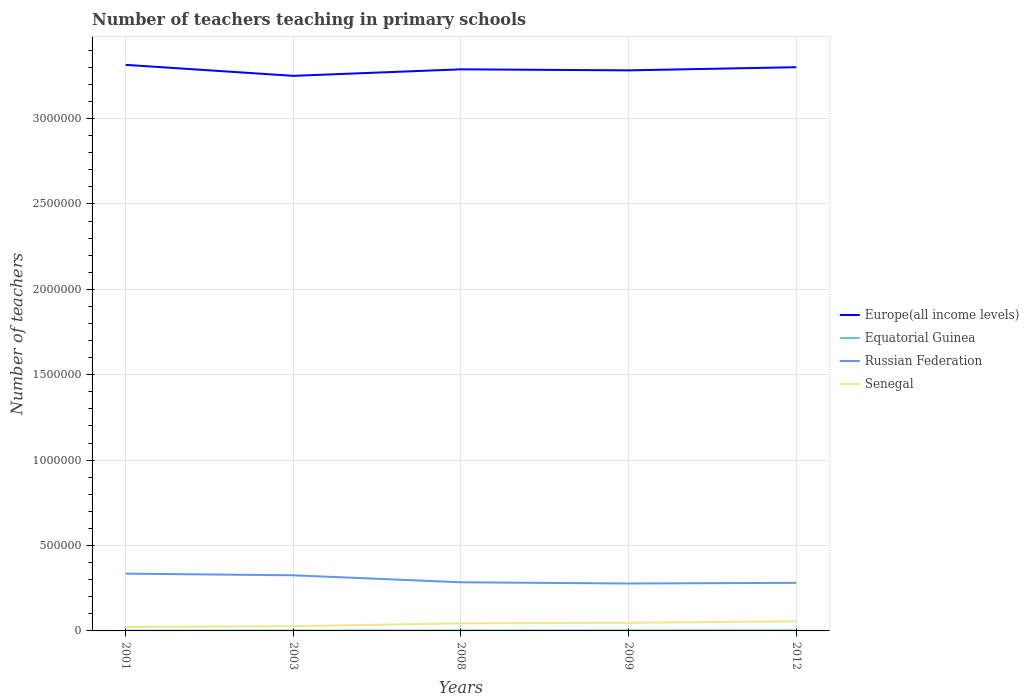Does the line corresponding to Europe(all income levels) intersect with the line corresponding to Equatorial Guinea?
Make the answer very short. No. Is the number of lines equal to the number of legend labels?
Keep it short and to the point. Yes. Across all years, what is the maximum number of teachers teaching in primary schools in Russian Federation?
Keep it short and to the point. 2.78e+05. In which year was the number of teachers teaching in primary schools in Europe(all income levels) maximum?
Your answer should be compact. 2003. What is the total number of teachers teaching in primary schools in Russian Federation in the graph?
Ensure brevity in your answer.  -3846. What is the difference between the highest and the second highest number of teachers teaching in primary schools in Europe(all income levels)?
Ensure brevity in your answer.  6.43e+04. How many lines are there?
Your response must be concise. 4. Are the values on the major ticks of Y-axis written in scientific E-notation?
Your answer should be very brief. No. How are the legend labels stacked?
Offer a terse response. Vertical. What is the title of the graph?
Your response must be concise. Number of teachers teaching in primary schools. What is the label or title of the Y-axis?
Make the answer very short. Number of teachers. What is the Number of teachers in Europe(all income levels) in 2001?
Your answer should be compact. 3.31e+06. What is the Number of teachers in Equatorial Guinea in 2001?
Your answer should be very brief. 1810. What is the Number of teachers of Russian Federation in 2001?
Offer a terse response. 3.36e+05. What is the Number of teachers of Senegal in 2001?
Keep it short and to the point. 2.28e+04. What is the Number of teachers of Europe(all income levels) in 2003?
Provide a succinct answer. 3.25e+06. What is the Number of teachers in Equatorial Guinea in 2003?
Provide a short and direct response. 2307. What is the Number of teachers in Russian Federation in 2003?
Your answer should be very brief. 3.26e+05. What is the Number of teachers of Senegal in 2003?
Offer a very short reply. 2.80e+04. What is the Number of teachers in Europe(all income levels) in 2008?
Your answer should be compact. 3.29e+06. What is the Number of teachers in Equatorial Guinea in 2008?
Keep it short and to the point. 2900. What is the Number of teachers in Russian Federation in 2008?
Your answer should be compact. 2.85e+05. What is the Number of teachers of Senegal in 2008?
Offer a terse response. 4.44e+04. What is the Number of teachers of Europe(all income levels) in 2009?
Your answer should be very brief. 3.28e+06. What is the Number of teachers of Equatorial Guinea in 2009?
Provide a succinct answer. 3403. What is the Number of teachers of Russian Federation in 2009?
Your answer should be very brief. 2.78e+05. What is the Number of teachers in Senegal in 2009?
Your answer should be very brief. 4.77e+04. What is the Number of teachers in Europe(all income levels) in 2012?
Offer a terse response. 3.30e+06. What is the Number of teachers in Equatorial Guinea in 2012?
Offer a terse response. 3517. What is the Number of teachers of Russian Federation in 2012?
Your answer should be compact. 2.82e+05. What is the Number of teachers of Senegal in 2012?
Keep it short and to the point. 5.63e+04. Across all years, what is the maximum Number of teachers of Europe(all income levels)?
Provide a succinct answer. 3.31e+06. Across all years, what is the maximum Number of teachers of Equatorial Guinea?
Your answer should be very brief. 3517. Across all years, what is the maximum Number of teachers of Russian Federation?
Offer a terse response. 3.36e+05. Across all years, what is the maximum Number of teachers of Senegal?
Provide a short and direct response. 5.63e+04. Across all years, what is the minimum Number of teachers of Europe(all income levels)?
Make the answer very short. 3.25e+06. Across all years, what is the minimum Number of teachers in Equatorial Guinea?
Provide a succinct answer. 1810. Across all years, what is the minimum Number of teachers of Russian Federation?
Keep it short and to the point. 2.78e+05. Across all years, what is the minimum Number of teachers in Senegal?
Keep it short and to the point. 2.28e+04. What is the total Number of teachers in Europe(all income levels) in the graph?
Give a very brief answer. 1.64e+07. What is the total Number of teachers of Equatorial Guinea in the graph?
Give a very brief answer. 1.39e+04. What is the total Number of teachers in Russian Federation in the graph?
Your answer should be compact. 1.51e+06. What is the total Number of teachers in Senegal in the graph?
Make the answer very short. 1.99e+05. What is the difference between the Number of teachers in Europe(all income levels) in 2001 and that in 2003?
Offer a very short reply. 6.43e+04. What is the difference between the Number of teachers in Equatorial Guinea in 2001 and that in 2003?
Ensure brevity in your answer.  -497. What is the difference between the Number of teachers of Russian Federation in 2001 and that in 2003?
Offer a very short reply. 9833. What is the difference between the Number of teachers of Senegal in 2001 and that in 2003?
Provide a succinct answer. -5138. What is the difference between the Number of teachers of Europe(all income levels) in 2001 and that in 2008?
Offer a very short reply. 2.61e+04. What is the difference between the Number of teachers in Equatorial Guinea in 2001 and that in 2008?
Make the answer very short. -1090. What is the difference between the Number of teachers of Russian Federation in 2001 and that in 2008?
Ensure brevity in your answer.  5.07e+04. What is the difference between the Number of teachers in Senegal in 2001 and that in 2008?
Your response must be concise. -2.16e+04. What is the difference between the Number of teachers of Europe(all income levels) in 2001 and that in 2009?
Make the answer very short. 3.22e+04. What is the difference between the Number of teachers in Equatorial Guinea in 2001 and that in 2009?
Ensure brevity in your answer.  -1593. What is the difference between the Number of teachers in Russian Federation in 2001 and that in 2009?
Offer a very short reply. 5.78e+04. What is the difference between the Number of teachers of Senegal in 2001 and that in 2009?
Your answer should be compact. -2.49e+04. What is the difference between the Number of teachers of Europe(all income levels) in 2001 and that in 2012?
Provide a succinct answer. 1.37e+04. What is the difference between the Number of teachers of Equatorial Guinea in 2001 and that in 2012?
Your response must be concise. -1707. What is the difference between the Number of teachers of Russian Federation in 2001 and that in 2012?
Make the answer very short. 5.40e+04. What is the difference between the Number of teachers of Senegal in 2001 and that in 2012?
Your response must be concise. -3.35e+04. What is the difference between the Number of teachers of Europe(all income levels) in 2003 and that in 2008?
Ensure brevity in your answer.  -3.81e+04. What is the difference between the Number of teachers in Equatorial Guinea in 2003 and that in 2008?
Your answer should be compact. -593. What is the difference between the Number of teachers of Russian Federation in 2003 and that in 2008?
Ensure brevity in your answer.  4.09e+04. What is the difference between the Number of teachers of Senegal in 2003 and that in 2008?
Ensure brevity in your answer.  -1.65e+04. What is the difference between the Number of teachers in Europe(all income levels) in 2003 and that in 2009?
Make the answer very short. -3.21e+04. What is the difference between the Number of teachers in Equatorial Guinea in 2003 and that in 2009?
Offer a terse response. -1096. What is the difference between the Number of teachers in Russian Federation in 2003 and that in 2009?
Ensure brevity in your answer.  4.80e+04. What is the difference between the Number of teachers in Senegal in 2003 and that in 2009?
Your answer should be very brief. -1.97e+04. What is the difference between the Number of teachers of Europe(all income levels) in 2003 and that in 2012?
Provide a succinct answer. -5.06e+04. What is the difference between the Number of teachers of Equatorial Guinea in 2003 and that in 2012?
Give a very brief answer. -1210. What is the difference between the Number of teachers in Russian Federation in 2003 and that in 2012?
Provide a succinct answer. 4.42e+04. What is the difference between the Number of teachers in Senegal in 2003 and that in 2012?
Ensure brevity in your answer.  -2.83e+04. What is the difference between the Number of teachers of Europe(all income levels) in 2008 and that in 2009?
Offer a terse response. 6013.25. What is the difference between the Number of teachers in Equatorial Guinea in 2008 and that in 2009?
Ensure brevity in your answer.  -503. What is the difference between the Number of teachers of Russian Federation in 2008 and that in 2009?
Give a very brief answer. 7132. What is the difference between the Number of teachers in Senegal in 2008 and that in 2009?
Keep it short and to the point. -3269. What is the difference between the Number of teachers in Europe(all income levels) in 2008 and that in 2012?
Provide a short and direct response. -1.24e+04. What is the difference between the Number of teachers in Equatorial Guinea in 2008 and that in 2012?
Keep it short and to the point. -617. What is the difference between the Number of teachers in Russian Federation in 2008 and that in 2012?
Offer a terse response. 3286. What is the difference between the Number of teachers of Senegal in 2008 and that in 2012?
Give a very brief answer. -1.19e+04. What is the difference between the Number of teachers in Europe(all income levels) in 2009 and that in 2012?
Keep it short and to the point. -1.84e+04. What is the difference between the Number of teachers in Equatorial Guinea in 2009 and that in 2012?
Keep it short and to the point. -114. What is the difference between the Number of teachers in Russian Federation in 2009 and that in 2012?
Give a very brief answer. -3846. What is the difference between the Number of teachers in Senegal in 2009 and that in 2012?
Offer a terse response. -8599. What is the difference between the Number of teachers of Europe(all income levels) in 2001 and the Number of teachers of Equatorial Guinea in 2003?
Your response must be concise. 3.31e+06. What is the difference between the Number of teachers in Europe(all income levels) in 2001 and the Number of teachers in Russian Federation in 2003?
Offer a very short reply. 2.99e+06. What is the difference between the Number of teachers in Europe(all income levels) in 2001 and the Number of teachers in Senegal in 2003?
Your answer should be very brief. 3.29e+06. What is the difference between the Number of teachers in Equatorial Guinea in 2001 and the Number of teachers in Russian Federation in 2003?
Give a very brief answer. -3.24e+05. What is the difference between the Number of teachers in Equatorial Guinea in 2001 and the Number of teachers in Senegal in 2003?
Offer a very short reply. -2.61e+04. What is the difference between the Number of teachers of Russian Federation in 2001 and the Number of teachers of Senegal in 2003?
Provide a succinct answer. 3.08e+05. What is the difference between the Number of teachers of Europe(all income levels) in 2001 and the Number of teachers of Equatorial Guinea in 2008?
Make the answer very short. 3.31e+06. What is the difference between the Number of teachers of Europe(all income levels) in 2001 and the Number of teachers of Russian Federation in 2008?
Your answer should be very brief. 3.03e+06. What is the difference between the Number of teachers of Europe(all income levels) in 2001 and the Number of teachers of Senegal in 2008?
Give a very brief answer. 3.27e+06. What is the difference between the Number of teachers of Equatorial Guinea in 2001 and the Number of teachers of Russian Federation in 2008?
Make the answer very short. -2.83e+05. What is the difference between the Number of teachers of Equatorial Guinea in 2001 and the Number of teachers of Senegal in 2008?
Provide a short and direct response. -4.26e+04. What is the difference between the Number of teachers in Russian Federation in 2001 and the Number of teachers in Senegal in 2008?
Your response must be concise. 2.91e+05. What is the difference between the Number of teachers of Europe(all income levels) in 2001 and the Number of teachers of Equatorial Guinea in 2009?
Offer a terse response. 3.31e+06. What is the difference between the Number of teachers in Europe(all income levels) in 2001 and the Number of teachers in Russian Federation in 2009?
Provide a succinct answer. 3.04e+06. What is the difference between the Number of teachers in Europe(all income levels) in 2001 and the Number of teachers in Senegal in 2009?
Offer a very short reply. 3.27e+06. What is the difference between the Number of teachers of Equatorial Guinea in 2001 and the Number of teachers of Russian Federation in 2009?
Offer a very short reply. -2.76e+05. What is the difference between the Number of teachers of Equatorial Guinea in 2001 and the Number of teachers of Senegal in 2009?
Your answer should be compact. -4.59e+04. What is the difference between the Number of teachers in Russian Federation in 2001 and the Number of teachers in Senegal in 2009?
Provide a succinct answer. 2.88e+05. What is the difference between the Number of teachers of Europe(all income levels) in 2001 and the Number of teachers of Equatorial Guinea in 2012?
Your answer should be very brief. 3.31e+06. What is the difference between the Number of teachers of Europe(all income levels) in 2001 and the Number of teachers of Russian Federation in 2012?
Give a very brief answer. 3.03e+06. What is the difference between the Number of teachers in Europe(all income levels) in 2001 and the Number of teachers in Senegal in 2012?
Your answer should be very brief. 3.26e+06. What is the difference between the Number of teachers in Equatorial Guinea in 2001 and the Number of teachers in Russian Federation in 2012?
Make the answer very short. -2.80e+05. What is the difference between the Number of teachers in Equatorial Guinea in 2001 and the Number of teachers in Senegal in 2012?
Provide a short and direct response. -5.45e+04. What is the difference between the Number of teachers of Russian Federation in 2001 and the Number of teachers of Senegal in 2012?
Make the answer very short. 2.79e+05. What is the difference between the Number of teachers in Europe(all income levels) in 2003 and the Number of teachers in Equatorial Guinea in 2008?
Your response must be concise. 3.25e+06. What is the difference between the Number of teachers in Europe(all income levels) in 2003 and the Number of teachers in Russian Federation in 2008?
Offer a very short reply. 2.97e+06. What is the difference between the Number of teachers of Europe(all income levels) in 2003 and the Number of teachers of Senegal in 2008?
Ensure brevity in your answer.  3.21e+06. What is the difference between the Number of teachers of Equatorial Guinea in 2003 and the Number of teachers of Russian Federation in 2008?
Your answer should be compact. -2.82e+05. What is the difference between the Number of teachers in Equatorial Guinea in 2003 and the Number of teachers in Senegal in 2008?
Provide a succinct answer. -4.21e+04. What is the difference between the Number of teachers in Russian Federation in 2003 and the Number of teachers in Senegal in 2008?
Give a very brief answer. 2.81e+05. What is the difference between the Number of teachers in Europe(all income levels) in 2003 and the Number of teachers in Equatorial Guinea in 2009?
Ensure brevity in your answer.  3.25e+06. What is the difference between the Number of teachers in Europe(all income levels) in 2003 and the Number of teachers in Russian Federation in 2009?
Give a very brief answer. 2.97e+06. What is the difference between the Number of teachers in Europe(all income levels) in 2003 and the Number of teachers in Senegal in 2009?
Your answer should be very brief. 3.20e+06. What is the difference between the Number of teachers in Equatorial Guinea in 2003 and the Number of teachers in Russian Federation in 2009?
Your response must be concise. -2.75e+05. What is the difference between the Number of teachers of Equatorial Guinea in 2003 and the Number of teachers of Senegal in 2009?
Your response must be concise. -4.54e+04. What is the difference between the Number of teachers in Russian Federation in 2003 and the Number of teachers in Senegal in 2009?
Offer a very short reply. 2.78e+05. What is the difference between the Number of teachers in Europe(all income levels) in 2003 and the Number of teachers in Equatorial Guinea in 2012?
Your answer should be very brief. 3.25e+06. What is the difference between the Number of teachers of Europe(all income levels) in 2003 and the Number of teachers of Russian Federation in 2012?
Offer a very short reply. 2.97e+06. What is the difference between the Number of teachers of Europe(all income levels) in 2003 and the Number of teachers of Senegal in 2012?
Your answer should be very brief. 3.19e+06. What is the difference between the Number of teachers of Equatorial Guinea in 2003 and the Number of teachers of Russian Federation in 2012?
Offer a very short reply. -2.79e+05. What is the difference between the Number of teachers in Equatorial Guinea in 2003 and the Number of teachers in Senegal in 2012?
Your response must be concise. -5.40e+04. What is the difference between the Number of teachers in Russian Federation in 2003 and the Number of teachers in Senegal in 2012?
Offer a very short reply. 2.69e+05. What is the difference between the Number of teachers in Europe(all income levels) in 2008 and the Number of teachers in Equatorial Guinea in 2009?
Provide a short and direct response. 3.28e+06. What is the difference between the Number of teachers of Europe(all income levels) in 2008 and the Number of teachers of Russian Federation in 2009?
Keep it short and to the point. 3.01e+06. What is the difference between the Number of teachers of Europe(all income levels) in 2008 and the Number of teachers of Senegal in 2009?
Keep it short and to the point. 3.24e+06. What is the difference between the Number of teachers of Equatorial Guinea in 2008 and the Number of teachers of Russian Federation in 2009?
Offer a terse response. -2.75e+05. What is the difference between the Number of teachers of Equatorial Guinea in 2008 and the Number of teachers of Senegal in 2009?
Your answer should be compact. -4.48e+04. What is the difference between the Number of teachers of Russian Federation in 2008 and the Number of teachers of Senegal in 2009?
Your answer should be very brief. 2.37e+05. What is the difference between the Number of teachers of Europe(all income levels) in 2008 and the Number of teachers of Equatorial Guinea in 2012?
Offer a very short reply. 3.28e+06. What is the difference between the Number of teachers of Europe(all income levels) in 2008 and the Number of teachers of Russian Federation in 2012?
Your answer should be compact. 3.01e+06. What is the difference between the Number of teachers in Europe(all income levels) in 2008 and the Number of teachers in Senegal in 2012?
Your answer should be very brief. 3.23e+06. What is the difference between the Number of teachers of Equatorial Guinea in 2008 and the Number of teachers of Russian Federation in 2012?
Your response must be concise. -2.79e+05. What is the difference between the Number of teachers of Equatorial Guinea in 2008 and the Number of teachers of Senegal in 2012?
Your answer should be very brief. -5.34e+04. What is the difference between the Number of teachers of Russian Federation in 2008 and the Number of teachers of Senegal in 2012?
Your answer should be very brief. 2.29e+05. What is the difference between the Number of teachers of Europe(all income levels) in 2009 and the Number of teachers of Equatorial Guinea in 2012?
Your response must be concise. 3.28e+06. What is the difference between the Number of teachers in Europe(all income levels) in 2009 and the Number of teachers in Russian Federation in 2012?
Ensure brevity in your answer.  3.00e+06. What is the difference between the Number of teachers in Europe(all income levels) in 2009 and the Number of teachers in Senegal in 2012?
Give a very brief answer. 3.23e+06. What is the difference between the Number of teachers of Equatorial Guinea in 2009 and the Number of teachers of Russian Federation in 2012?
Your answer should be very brief. -2.78e+05. What is the difference between the Number of teachers of Equatorial Guinea in 2009 and the Number of teachers of Senegal in 2012?
Your answer should be compact. -5.29e+04. What is the difference between the Number of teachers of Russian Federation in 2009 and the Number of teachers of Senegal in 2012?
Your answer should be compact. 2.21e+05. What is the average Number of teachers in Europe(all income levels) per year?
Provide a succinct answer. 3.29e+06. What is the average Number of teachers in Equatorial Guinea per year?
Offer a very short reply. 2787.4. What is the average Number of teachers of Russian Federation per year?
Your response must be concise. 3.01e+05. What is the average Number of teachers in Senegal per year?
Provide a succinct answer. 3.98e+04. In the year 2001, what is the difference between the Number of teachers in Europe(all income levels) and Number of teachers in Equatorial Guinea?
Your response must be concise. 3.31e+06. In the year 2001, what is the difference between the Number of teachers in Europe(all income levels) and Number of teachers in Russian Federation?
Provide a short and direct response. 2.98e+06. In the year 2001, what is the difference between the Number of teachers of Europe(all income levels) and Number of teachers of Senegal?
Provide a short and direct response. 3.29e+06. In the year 2001, what is the difference between the Number of teachers of Equatorial Guinea and Number of teachers of Russian Federation?
Provide a succinct answer. -3.34e+05. In the year 2001, what is the difference between the Number of teachers in Equatorial Guinea and Number of teachers in Senegal?
Make the answer very short. -2.10e+04. In the year 2001, what is the difference between the Number of teachers in Russian Federation and Number of teachers in Senegal?
Your answer should be very brief. 3.13e+05. In the year 2003, what is the difference between the Number of teachers of Europe(all income levels) and Number of teachers of Equatorial Guinea?
Your response must be concise. 3.25e+06. In the year 2003, what is the difference between the Number of teachers of Europe(all income levels) and Number of teachers of Russian Federation?
Give a very brief answer. 2.92e+06. In the year 2003, what is the difference between the Number of teachers in Europe(all income levels) and Number of teachers in Senegal?
Provide a short and direct response. 3.22e+06. In the year 2003, what is the difference between the Number of teachers of Equatorial Guinea and Number of teachers of Russian Federation?
Your response must be concise. -3.23e+05. In the year 2003, what is the difference between the Number of teachers in Equatorial Guinea and Number of teachers in Senegal?
Your response must be concise. -2.56e+04. In the year 2003, what is the difference between the Number of teachers of Russian Federation and Number of teachers of Senegal?
Ensure brevity in your answer.  2.98e+05. In the year 2008, what is the difference between the Number of teachers in Europe(all income levels) and Number of teachers in Equatorial Guinea?
Provide a succinct answer. 3.29e+06. In the year 2008, what is the difference between the Number of teachers of Europe(all income levels) and Number of teachers of Russian Federation?
Provide a short and direct response. 3.00e+06. In the year 2008, what is the difference between the Number of teachers in Europe(all income levels) and Number of teachers in Senegal?
Make the answer very short. 3.24e+06. In the year 2008, what is the difference between the Number of teachers in Equatorial Guinea and Number of teachers in Russian Federation?
Provide a short and direct response. -2.82e+05. In the year 2008, what is the difference between the Number of teachers of Equatorial Guinea and Number of teachers of Senegal?
Offer a terse response. -4.15e+04. In the year 2008, what is the difference between the Number of teachers in Russian Federation and Number of teachers in Senegal?
Keep it short and to the point. 2.40e+05. In the year 2009, what is the difference between the Number of teachers in Europe(all income levels) and Number of teachers in Equatorial Guinea?
Give a very brief answer. 3.28e+06. In the year 2009, what is the difference between the Number of teachers in Europe(all income levels) and Number of teachers in Russian Federation?
Ensure brevity in your answer.  3.00e+06. In the year 2009, what is the difference between the Number of teachers of Europe(all income levels) and Number of teachers of Senegal?
Ensure brevity in your answer.  3.23e+06. In the year 2009, what is the difference between the Number of teachers of Equatorial Guinea and Number of teachers of Russian Federation?
Provide a succinct answer. -2.74e+05. In the year 2009, what is the difference between the Number of teachers in Equatorial Guinea and Number of teachers in Senegal?
Ensure brevity in your answer.  -4.43e+04. In the year 2009, what is the difference between the Number of teachers in Russian Federation and Number of teachers in Senegal?
Make the answer very short. 2.30e+05. In the year 2012, what is the difference between the Number of teachers of Europe(all income levels) and Number of teachers of Equatorial Guinea?
Offer a terse response. 3.30e+06. In the year 2012, what is the difference between the Number of teachers in Europe(all income levels) and Number of teachers in Russian Federation?
Ensure brevity in your answer.  3.02e+06. In the year 2012, what is the difference between the Number of teachers of Europe(all income levels) and Number of teachers of Senegal?
Make the answer very short. 3.24e+06. In the year 2012, what is the difference between the Number of teachers of Equatorial Guinea and Number of teachers of Russian Federation?
Make the answer very short. -2.78e+05. In the year 2012, what is the difference between the Number of teachers of Equatorial Guinea and Number of teachers of Senegal?
Make the answer very short. -5.28e+04. In the year 2012, what is the difference between the Number of teachers of Russian Federation and Number of teachers of Senegal?
Provide a short and direct response. 2.25e+05. What is the ratio of the Number of teachers of Europe(all income levels) in 2001 to that in 2003?
Your response must be concise. 1.02. What is the ratio of the Number of teachers in Equatorial Guinea in 2001 to that in 2003?
Give a very brief answer. 0.78. What is the ratio of the Number of teachers of Russian Federation in 2001 to that in 2003?
Make the answer very short. 1.03. What is the ratio of the Number of teachers in Senegal in 2001 to that in 2003?
Offer a very short reply. 0.82. What is the ratio of the Number of teachers of Europe(all income levels) in 2001 to that in 2008?
Your answer should be very brief. 1.01. What is the ratio of the Number of teachers of Equatorial Guinea in 2001 to that in 2008?
Offer a very short reply. 0.62. What is the ratio of the Number of teachers of Russian Federation in 2001 to that in 2008?
Provide a short and direct response. 1.18. What is the ratio of the Number of teachers of Senegal in 2001 to that in 2008?
Offer a terse response. 0.51. What is the ratio of the Number of teachers of Europe(all income levels) in 2001 to that in 2009?
Keep it short and to the point. 1.01. What is the ratio of the Number of teachers in Equatorial Guinea in 2001 to that in 2009?
Your answer should be compact. 0.53. What is the ratio of the Number of teachers of Russian Federation in 2001 to that in 2009?
Provide a succinct answer. 1.21. What is the ratio of the Number of teachers in Senegal in 2001 to that in 2009?
Ensure brevity in your answer.  0.48. What is the ratio of the Number of teachers in Equatorial Guinea in 2001 to that in 2012?
Offer a terse response. 0.51. What is the ratio of the Number of teachers of Russian Federation in 2001 to that in 2012?
Your answer should be very brief. 1.19. What is the ratio of the Number of teachers of Senegal in 2001 to that in 2012?
Provide a short and direct response. 0.41. What is the ratio of the Number of teachers of Europe(all income levels) in 2003 to that in 2008?
Provide a short and direct response. 0.99. What is the ratio of the Number of teachers in Equatorial Guinea in 2003 to that in 2008?
Offer a very short reply. 0.8. What is the ratio of the Number of teachers in Russian Federation in 2003 to that in 2008?
Keep it short and to the point. 1.14. What is the ratio of the Number of teachers in Senegal in 2003 to that in 2008?
Make the answer very short. 0.63. What is the ratio of the Number of teachers in Europe(all income levels) in 2003 to that in 2009?
Your answer should be very brief. 0.99. What is the ratio of the Number of teachers of Equatorial Guinea in 2003 to that in 2009?
Offer a very short reply. 0.68. What is the ratio of the Number of teachers in Russian Federation in 2003 to that in 2009?
Make the answer very short. 1.17. What is the ratio of the Number of teachers in Senegal in 2003 to that in 2009?
Give a very brief answer. 0.59. What is the ratio of the Number of teachers in Europe(all income levels) in 2003 to that in 2012?
Provide a succinct answer. 0.98. What is the ratio of the Number of teachers of Equatorial Guinea in 2003 to that in 2012?
Give a very brief answer. 0.66. What is the ratio of the Number of teachers in Russian Federation in 2003 to that in 2012?
Provide a short and direct response. 1.16. What is the ratio of the Number of teachers of Senegal in 2003 to that in 2012?
Offer a terse response. 0.5. What is the ratio of the Number of teachers of Equatorial Guinea in 2008 to that in 2009?
Make the answer very short. 0.85. What is the ratio of the Number of teachers in Russian Federation in 2008 to that in 2009?
Offer a terse response. 1.03. What is the ratio of the Number of teachers in Senegal in 2008 to that in 2009?
Ensure brevity in your answer.  0.93. What is the ratio of the Number of teachers in Equatorial Guinea in 2008 to that in 2012?
Your answer should be compact. 0.82. What is the ratio of the Number of teachers in Russian Federation in 2008 to that in 2012?
Ensure brevity in your answer.  1.01. What is the ratio of the Number of teachers of Senegal in 2008 to that in 2012?
Your answer should be compact. 0.79. What is the ratio of the Number of teachers of Equatorial Guinea in 2009 to that in 2012?
Make the answer very short. 0.97. What is the ratio of the Number of teachers of Russian Federation in 2009 to that in 2012?
Your answer should be very brief. 0.99. What is the ratio of the Number of teachers of Senegal in 2009 to that in 2012?
Keep it short and to the point. 0.85. What is the difference between the highest and the second highest Number of teachers of Europe(all income levels)?
Your answer should be compact. 1.37e+04. What is the difference between the highest and the second highest Number of teachers in Equatorial Guinea?
Keep it short and to the point. 114. What is the difference between the highest and the second highest Number of teachers of Russian Federation?
Offer a very short reply. 9833. What is the difference between the highest and the second highest Number of teachers in Senegal?
Provide a short and direct response. 8599. What is the difference between the highest and the lowest Number of teachers of Europe(all income levels)?
Provide a short and direct response. 6.43e+04. What is the difference between the highest and the lowest Number of teachers of Equatorial Guinea?
Your answer should be very brief. 1707. What is the difference between the highest and the lowest Number of teachers in Russian Federation?
Offer a terse response. 5.78e+04. What is the difference between the highest and the lowest Number of teachers of Senegal?
Make the answer very short. 3.35e+04. 